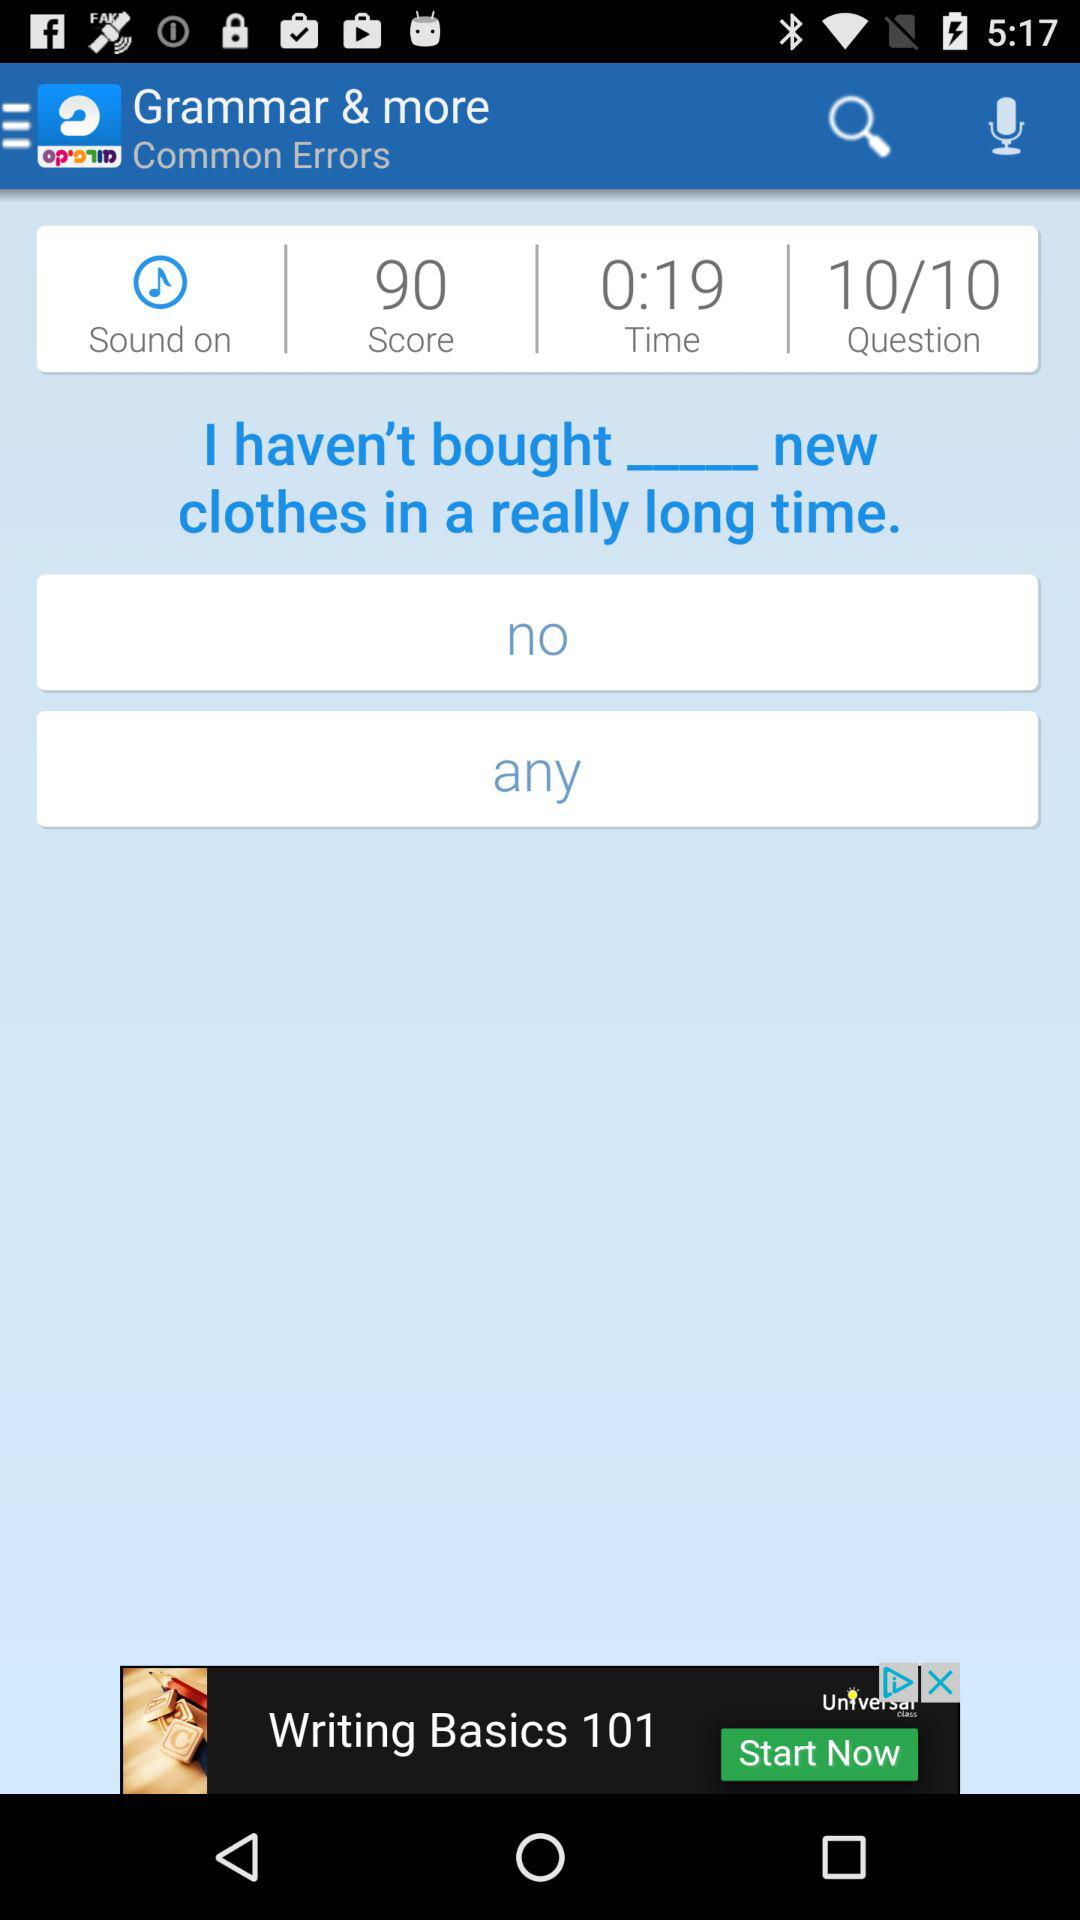What is the application name? The application name is "Morfix - English to Hebrew Tra". 